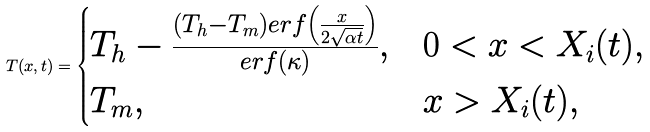Convert formula to latex. <formula><loc_0><loc_0><loc_500><loc_500>T ( x , t ) = \begin{cases} T _ { h } - \frac { ( T _ { h } - T _ { m } ) e r f \left ( \frac { x } { 2 \sqrt { \alpha t } } \right ) } { e r f ( \kappa ) } , & 0 < x < X _ { i } ( t ) , \\ T _ { m } , & x > X _ { i } ( t ) , \end{cases}</formula> 